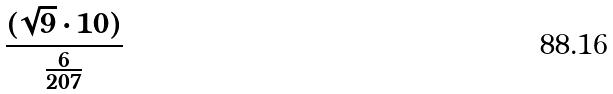Convert formula to latex. <formula><loc_0><loc_0><loc_500><loc_500>\frac { ( \sqrt { 9 } \cdot 1 0 ) } { \frac { 6 } { 2 0 7 } }</formula> 